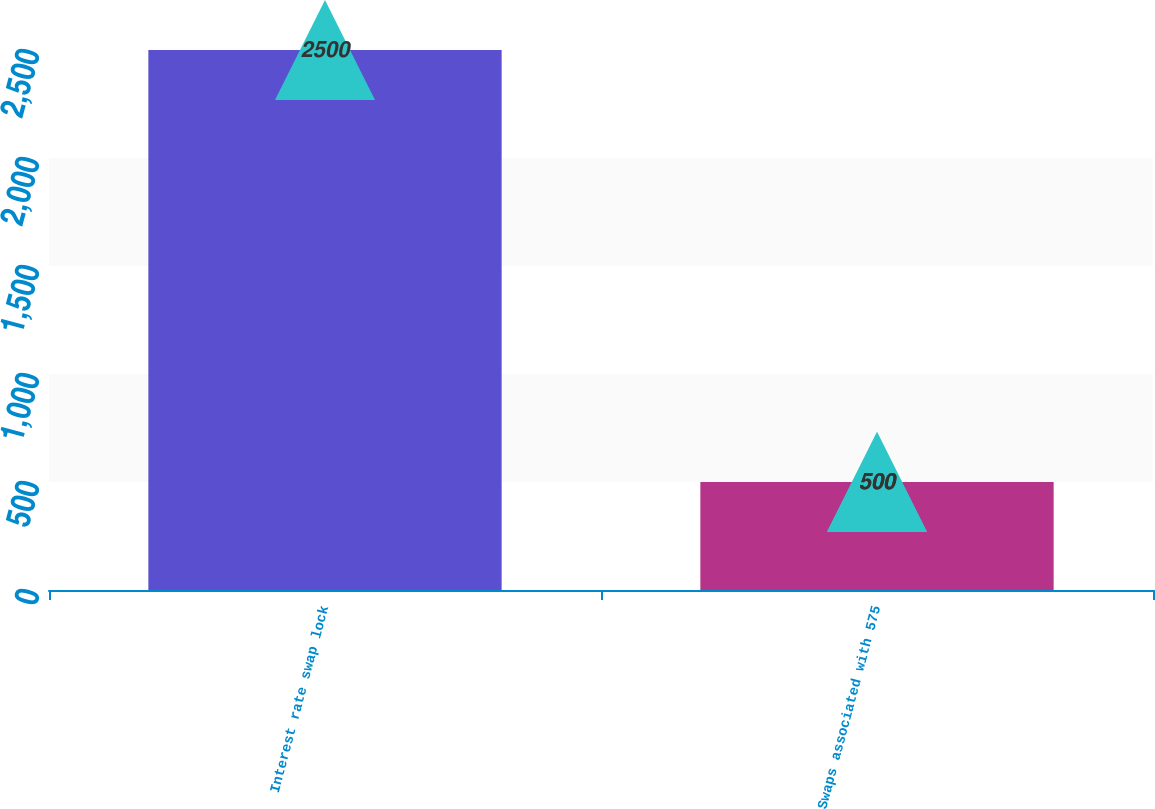<chart> <loc_0><loc_0><loc_500><loc_500><bar_chart><fcel>Interest rate swap lock<fcel>Swaps associated with 575<nl><fcel>2500<fcel>500<nl></chart> 